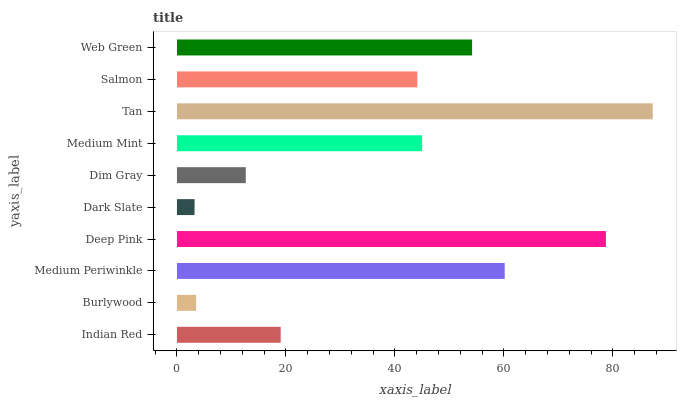Is Dark Slate the minimum?
Answer yes or no. Yes. Is Tan the maximum?
Answer yes or no. Yes. Is Burlywood the minimum?
Answer yes or no. No. Is Burlywood the maximum?
Answer yes or no. No. Is Indian Red greater than Burlywood?
Answer yes or no. Yes. Is Burlywood less than Indian Red?
Answer yes or no. Yes. Is Burlywood greater than Indian Red?
Answer yes or no. No. Is Indian Red less than Burlywood?
Answer yes or no. No. Is Medium Mint the high median?
Answer yes or no. Yes. Is Salmon the low median?
Answer yes or no. Yes. Is Tan the high median?
Answer yes or no. No. Is Deep Pink the low median?
Answer yes or no. No. 